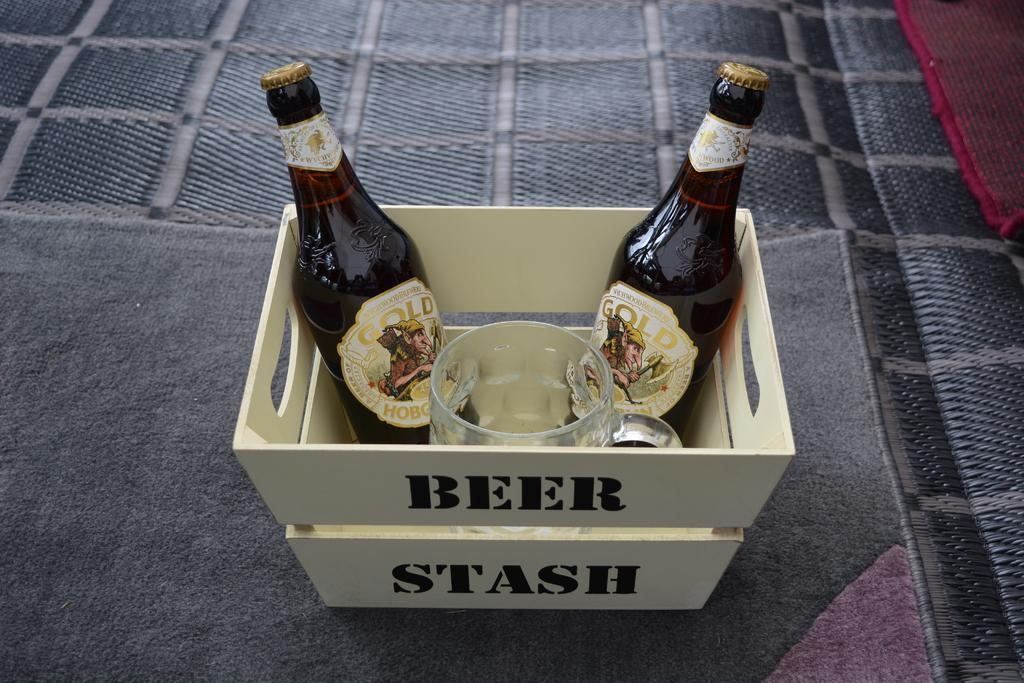<image>
Give a short and clear explanation of the subsequent image. Two beer bottles sit in a basket labeled "Beer Stash." 